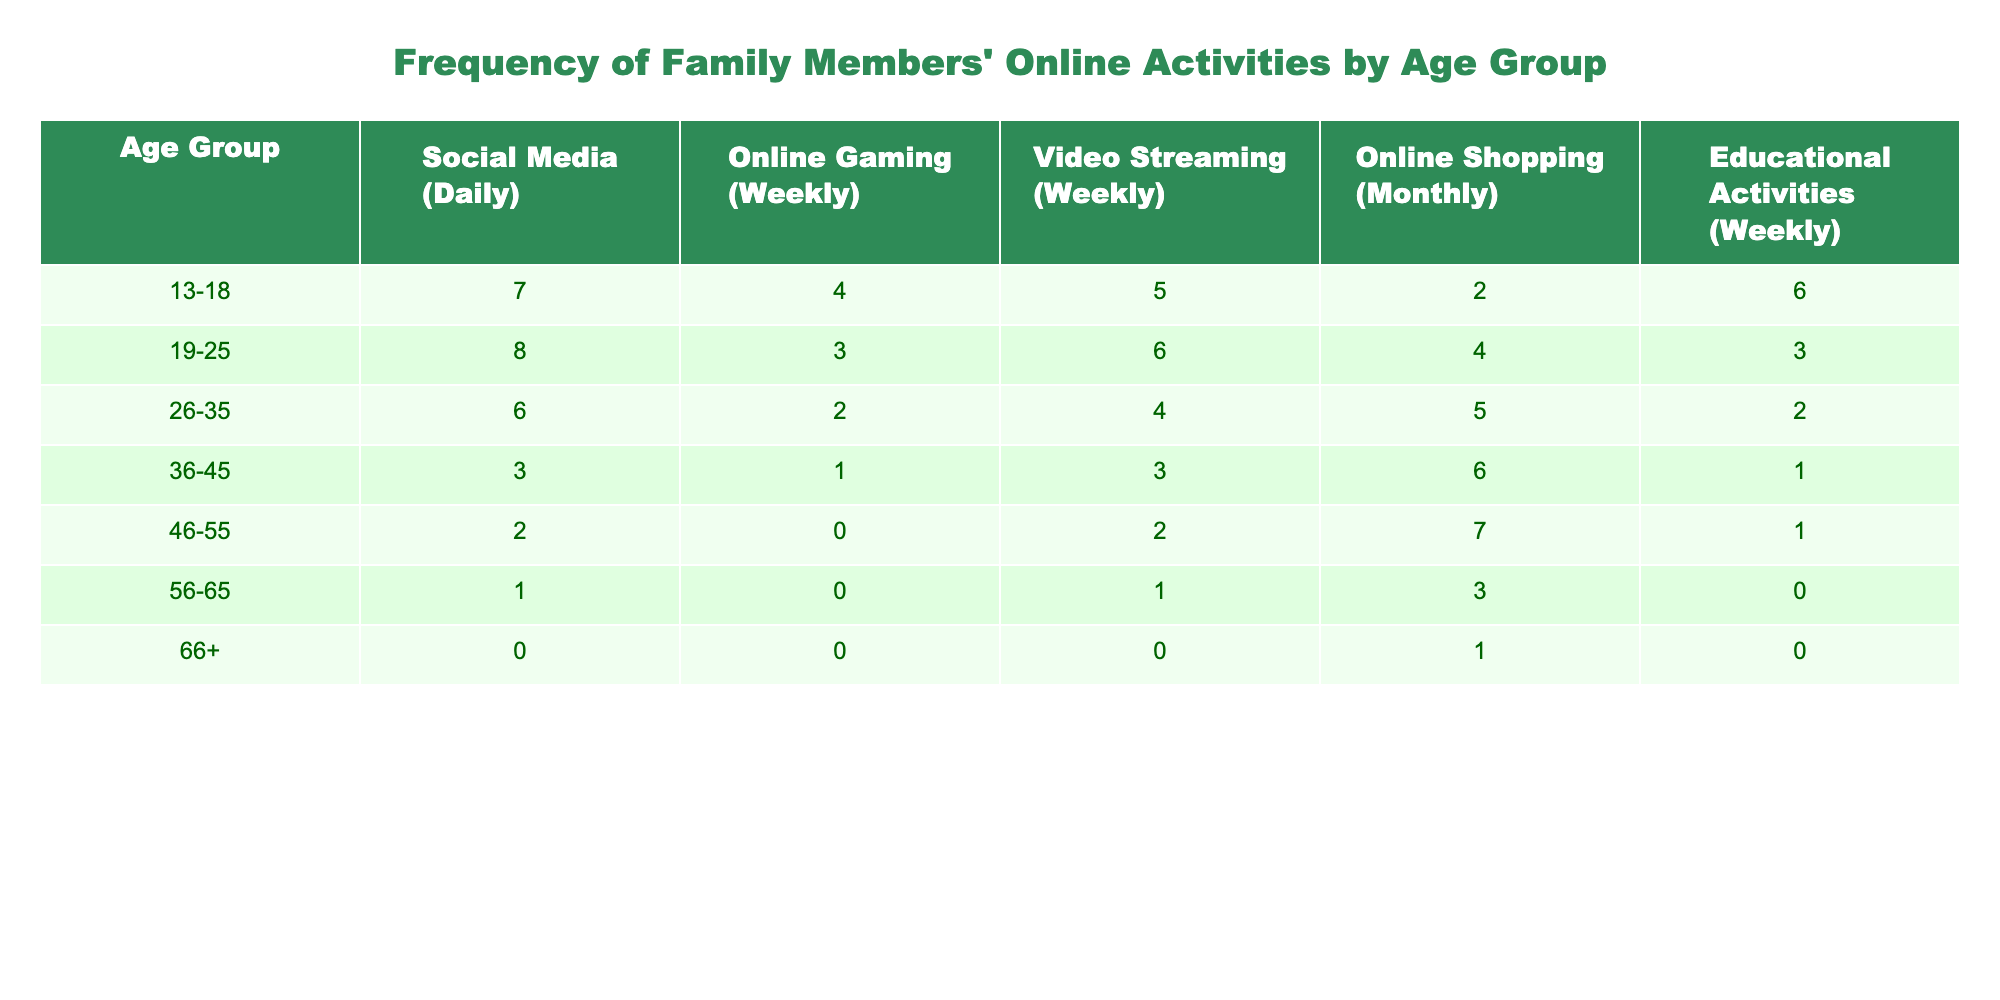What is the highest frequency of online gaming (weekly) in any age group? The highest frequency of online gaming (weekly) can be found by scanning the "Online Gaming (Weekly)" column. The maximum value here is clearly 4, which appears in the 13-18 age group.
Answer: 4 Which age group engages in educational activities (weekly) the most? By looking at the "Educational Activities (Weekly)" column, we find that the 13-18 age group has the highest frequency of 6 activities, compared to all other age groups.
Answer: 13-18 How many total online shopping activities (monthly) are reported across all age groups? We need to sum the values in the "Online Shopping (Monthly)" column: 2 (13-18) + 4 (19-25) + 5 (26-35) + 6 (36-45) + 7 (46-55) + 3 (56-65) + 1 (66+) = 28.
Answer: 28 Is it true that more than half of the age groups engage in social media daily? To answer this, we check the "Social Media (Daily)" column. Out of the 7 age groups, 5 have a frequency greater than 0. That means more than half (5 out of 7 groups) does engage in social media daily.
Answer: Yes What is the average frequency of video streaming (weekly) for the age groups 26-35 and 36-45 combined? First, we find the values for those age groups in the "Video Streaming (Weekly)" column: 4 (26-35) and 3 (36-45). We then sum these values (4 + 3 = 7) and divide by 2 to find the average: 7 / 2 = 3.5.
Answer: 3.5 Which activity has the lowest frequency for individuals aged 56-65? Looking at the row for the 56-65 age group in all columns, we see that the lowest frequency is 0, which applies to both online gaming and educational activities.
Answer: 0 How does the frequency of online shopping compare between the age groups 46-55 and 56-65? In the "Online Shopping (Monthly)" column, the frequency for 46-55 is 7, while for 56-65 it is 3. Therefore, the 46-55 age group participates in online shopping more frequently than the 56-65 age group.
Answer: More frequently in 46-55 What is the total frequency of online activities for the age group 19-25? To find the total frequency for 19-25, we add all the values in that age group's row: 8 (social media) + 3 (gaming) + 6 (streaming) + 4 (shopping) + 3 (educational) = 24.
Answer: 24 Which activity shows a decreasing trend as age increases? By reviewing each column, it's clear that the frequency of social media usage consistently decreases as the age groups get older. The counts decrease from 7 in the youngest group down to 0 in the oldest.
Answer: Social Media 